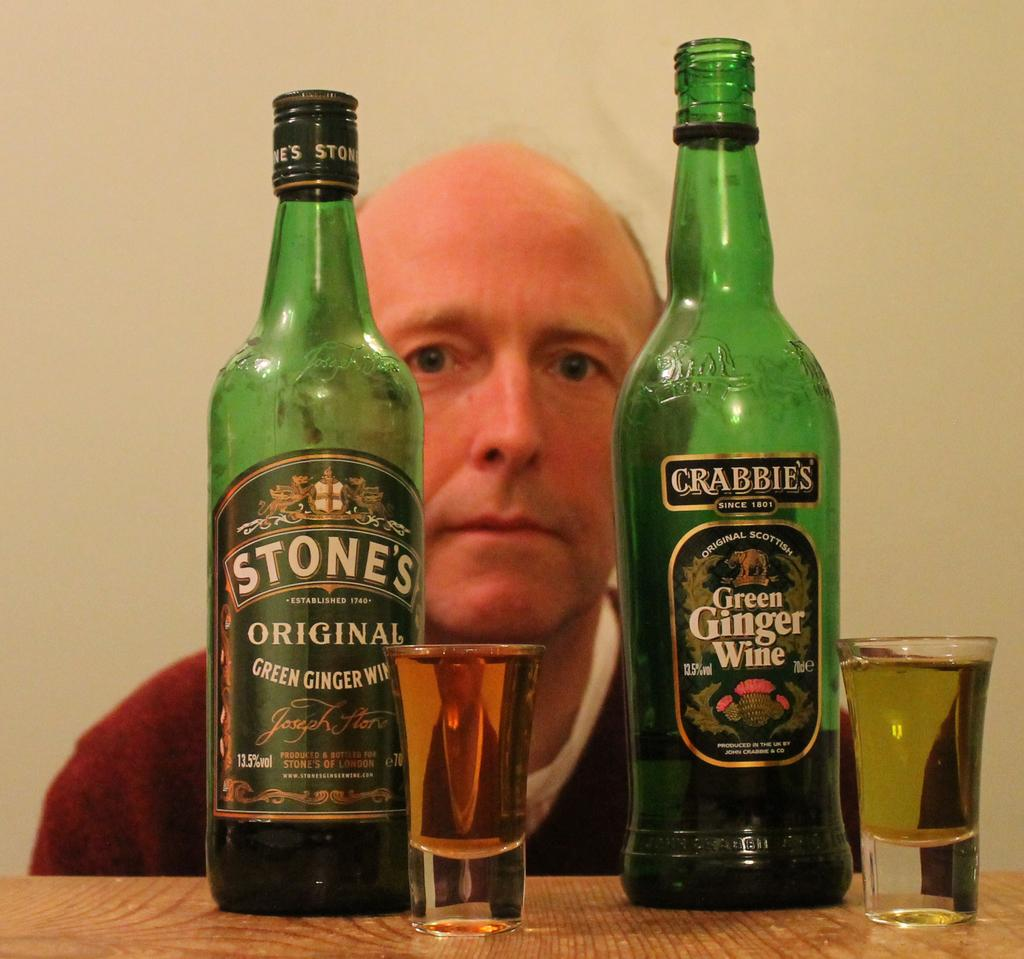Provide a one-sentence caption for the provided image. A man is behind two different varieties of green ginger wine. 